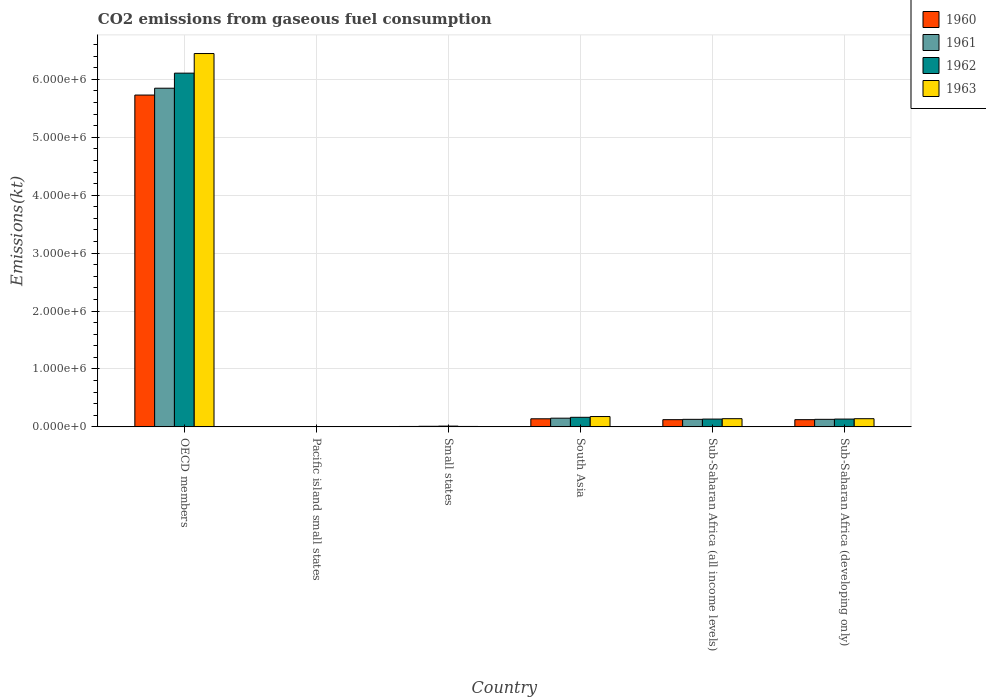How many different coloured bars are there?
Provide a short and direct response. 4. What is the label of the 1st group of bars from the left?
Make the answer very short. OECD members. What is the amount of CO2 emitted in 1962 in South Asia?
Give a very brief answer. 1.65e+05. Across all countries, what is the maximum amount of CO2 emitted in 1961?
Your answer should be compact. 5.85e+06. Across all countries, what is the minimum amount of CO2 emitted in 1961?
Provide a succinct answer. 332.61. In which country was the amount of CO2 emitted in 1960 minimum?
Ensure brevity in your answer.  Pacific island small states. What is the total amount of CO2 emitted in 1961 in the graph?
Keep it short and to the point. 6.27e+06. What is the difference between the amount of CO2 emitted in 1961 in Pacific island small states and that in Sub-Saharan Africa (all income levels)?
Offer a terse response. -1.30e+05. What is the difference between the amount of CO2 emitted in 1961 in OECD members and the amount of CO2 emitted in 1962 in Sub-Saharan Africa (developing only)?
Your response must be concise. 5.71e+06. What is the average amount of CO2 emitted in 1963 per country?
Offer a terse response. 1.15e+06. What is the difference between the amount of CO2 emitted of/in 1962 and amount of CO2 emitted of/in 1960 in OECD members?
Offer a very short reply. 3.78e+05. In how many countries, is the amount of CO2 emitted in 1962 greater than 6200000 kt?
Give a very brief answer. 0. What is the ratio of the amount of CO2 emitted in 1961 in Pacific island small states to that in Sub-Saharan Africa (developing only)?
Offer a terse response. 0. Is the difference between the amount of CO2 emitted in 1962 in Small states and Sub-Saharan Africa (developing only) greater than the difference between the amount of CO2 emitted in 1960 in Small states and Sub-Saharan Africa (developing only)?
Provide a succinct answer. No. What is the difference between the highest and the second highest amount of CO2 emitted in 1963?
Offer a very short reply. 6.30e+06. What is the difference between the highest and the lowest amount of CO2 emitted in 1963?
Your response must be concise. 6.45e+06. Is the sum of the amount of CO2 emitted in 1960 in Small states and South Asia greater than the maximum amount of CO2 emitted in 1962 across all countries?
Give a very brief answer. No. Is it the case that in every country, the sum of the amount of CO2 emitted in 1961 and amount of CO2 emitted in 1962 is greater than the sum of amount of CO2 emitted in 1963 and amount of CO2 emitted in 1960?
Give a very brief answer. No. What does the 2nd bar from the right in Pacific island small states represents?
Provide a short and direct response. 1962. Is it the case that in every country, the sum of the amount of CO2 emitted in 1963 and amount of CO2 emitted in 1962 is greater than the amount of CO2 emitted in 1960?
Provide a succinct answer. Yes. Are all the bars in the graph horizontal?
Give a very brief answer. No. How many countries are there in the graph?
Make the answer very short. 6. What is the difference between two consecutive major ticks on the Y-axis?
Your answer should be compact. 1.00e+06. How many legend labels are there?
Your answer should be compact. 4. How are the legend labels stacked?
Your answer should be very brief. Vertical. What is the title of the graph?
Provide a succinct answer. CO2 emissions from gaseous fuel consumption. What is the label or title of the Y-axis?
Give a very brief answer. Emissions(kt). What is the Emissions(kt) in 1960 in OECD members?
Your response must be concise. 5.73e+06. What is the Emissions(kt) of 1961 in OECD members?
Make the answer very short. 5.85e+06. What is the Emissions(kt) of 1962 in OECD members?
Offer a very short reply. 6.11e+06. What is the Emissions(kt) of 1963 in OECD members?
Keep it short and to the point. 6.45e+06. What is the Emissions(kt) of 1960 in Pacific island small states?
Keep it short and to the point. 309.51. What is the Emissions(kt) in 1961 in Pacific island small states?
Offer a very short reply. 332.61. What is the Emissions(kt) of 1962 in Pacific island small states?
Offer a terse response. 413.52. What is the Emissions(kt) in 1963 in Pacific island small states?
Your answer should be very brief. 433.59. What is the Emissions(kt) in 1960 in Small states?
Give a very brief answer. 7013.94. What is the Emissions(kt) of 1961 in Small states?
Make the answer very short. 1.02e+04. What is the Emissions(kt) in 1962 in Small states?
Give a very brief answer. 1.34e+04. What is the Emissions(kt) in 1963 in Small states?
Your answer should be compact. 7256.39. What is the Emissions(kt) in 1960 in South Asia?
Provide a short and direct response. 1.39e+05. What is the Emissions(kt) of 1961 in South Asia?
Your response must be concise. 1.50e+05. What is the Emissions(kt) of 1962 in South Asia?
Give a very brief answer. 1.65e+05. What is the Emissions(kt) of 1963 in South Asia?
Keep it short and to the point. 1.78e+05. What is the Emissions(kt) of 1960 in Sub-Saharan Africa (all income levels)?
Give a very brief answer. 1.25e+05. What is the Emissions(kt) in 1961 in Sub-Saharan Africa (all income levels)?
Provide a succinct answer. 1.30e+05. What is the Emissions(kt) in 1962 in Sub-Saharan Africa (all income levels)?
Make the answer very short. 1.35e+05. What is the Emissions(kt) of 1963 in Sub-Saharan Africa (all income levels)?
Your answer should be compact. 1.41e+05. What is the Emissions(kt) in 1960 in Sub-Saharan Africa (developing only)?
Make the answer very short. 1.24e+05. What is the Emissions(kt) of 1961 in Sub-Saharan Africa (developing only)?
Your answer should be very brief. 1.30e+05. What is the Emissions(kt) in 1962 in Sub-Saharan Africa (developing only)?
Offer a very short reply. 1.35e+05. What is the Emissions(kt) of 1963 in Sub-Saharan Africa (developing only)?
Ensure brevity in your answer.  1.41e+05. Across all countries, what is the maximum Emissions(kt) of 1960?
Provide a succinct answer. 5.73e+06. Across all countries, what is the maximum Emissions(kt) in 1961?
Your answer should be very brief. 5.85e+06. Across all countries, what is the maximum Emissions(kt) of 1962?
Your answer should be compact. 6.11e+06. Across all countries, what is the maximum Emissions(kt) in 1963?
Give a very brief answer. 6.45e+06. Across all countries, what is the minimum Emissions(kt) in 1960?
Your response must be concise. 309.51. Across all countries, what is the minimum Emissions(kt) of 1961?
Provide a succinct answer. 332.61. Across all countries, what is the minimum Emissions(kt) of 1962?
Provide a succinct answer. 413.52. Across all countries, what is the minimum Emissions(kt) of 1963?
Provide a short and direct response. 433.59. What is the total Emissions(kt) in 1960 in the graph?
Your answer should be compact. 6.13e+06. What is the total Emissions(kt) in 1961 in the graph?
Ensure brevity in your answer.  6.27e+06. What is the total Emissions(kt) of 1962 in the graph?
Keep it short and to the point. 6.56e+06. What is the total Emissions(kt) in 1963 in the graph?
Your answer should be very brief. 6.92e+06. What is the difference between the Emissions(kt) of 1960 in OECD members and that in Pacific island small states?
Your answer should be very brief. 5.73e+06. What is the difference between the Emissions(kt) in 1961 in OECD members and that in Pacific island small states?
Ensure brevity in your answer.  5.85e+06. What is the difference between the Emissions(kt) in 1962 in OECD members and that in Pacific island small states?
Provide a short and direct response. 6.11e+06. What is the difference between the Emissions(kt) in 1963 in OECD members and that in Pacific island small states?
Your answer should be compact. 6.45e+06. What is the difference between the Emissions(kt) of 1960 in OECD members and that in Small states?
Your response must be concise. 5.72e+06. What is the difference between the Emissions(kt) in 1961 in OECD members and that in Small states?
Offer a terse response. 5.84e+06. What is the difference between the Emissions(kt) in 1962 in OECD members and that in Small states?
Make the answer very short. 6.09e+06. What is the difference between the Emissions(kt) of 1963 in OECD members and that in Small states?
Your answer should be very brief. 6.44e+06. What is the difference between the Emissions(kt) of 1960 in OECD members and that in South Asia?
Ensure brevity in your answer.  5.59e+06. What is the difference between the Emissions(kt) of 1961 in OECD members and that in South Asia?
Offer a terse response. 5.70e+06. What is the difference between the Emissions(kt) in 1962 in OECD members and that in South Asia?
Your answer should be very brief. 5.94e+06. What is the difference between the Emissions(kt) in 1963 in OECD members and that in South Asia?
Make the answer very short. 6.27e+06. What is the difference between the Emissions(kt) of 1960 in OECD members and that in Sub-Saharan Africa (all income levels)?
Give a very brief answer. 5.60e+06. What is the difference between the Emissions(kt) of 1961 in OECD members and that in Sub-Saharan Africa (all income levels)?
Provide a short and direct response. 5.72e+06. What is the difference between the Emissions(kt) of 1962 in OECD members and that in Sub-Saharan Africa (all income levels)?
Your response must be concise. 5.97e+06. What is the difference between the Emissions(kt) in 1963 in OECD members and that in Sub-Saharan Africa (all income levels)?
Provide a short and direct response. 6.30e+06. What is the difference between the Emissions(kt) of 1960 in OECD members and that in Sub-Saharan Africa (developing only)?
Your answer should be compact. 5.61e+06. What is the difference between the Emissions(kt) in 1961 in OECD members and that in Sub-Saharan Africa (developing only)?
Keep it short and to the point. 5.72e+06. What is the difference between the Emissions(kt) of 1962 in OECD members and that in Sub-Saharan Africa (developing only)?
Your response must be concise. 5.97e+06. What is the difference between the Emissions(kt) of 1963 in OECD members and that in Sub-Saharan Africa (developing only)?
Your answer should be compact. 6.30e+06. What is the difference between the Emissions(kt) of 1960 in Pacific island small states and that in Small states?
Offer a terse response. -6704.42. What is the difference between the Emissions(kt) of 1961 in Pacific island small states and that in Small states?
Your answer should be very brief. -9836.23. What is the difference between the Emissions(kt) in 1962 in Pacific island small states and that in Small states?
Keep it short and to the point. -1.30e+04. What is the difference between the Emissions(kt) of 1963 in Pacific island small states and that in Small states?
Your response must be concise. -6822.8. What is the difference between the Emissions(kt) in 1960 in Pacific island small states and that in South Asia?
Your answer should be very brief. -1.39e+05. What is the difference between the Emissions(kt) of 1961 in Pacific island small states and that in South Asia?
Give a very brief answer. -1.50e+05. What is the difference between the Emissions(kt) in 1962 in Pacific island small states and that in South Asia?
Keep it short and to the point. -1.65e+05. What is the difference between the Emissions(kt) of 1963 in Pacific island small states and that in South Asia?
Your answer should be compact. -1.78e+05. What is the difference between the Emissions(kt) in 1960 in Pacific island small states and that in Sub-Saharan Africa (all income levels)?
Provide a short and direct response. -1.24e+05. What is the difference between the Emissions(kt) of 1961 in Pacific island small states and that in Sub-Saharan Africa (all income levels)?
Give a very brief answer. -1.30e+05. What is the difference between the Emissions(kt) of 1962 in Pacific island small states and that in Sub-Saharan Africa (all income levels)?
Offer a terse response. -1.34e+05. What is the difference between the Emissions(kt) of 1963 in Pacific island small states and that in Sub-Saharan Africa (all income levels)?
Keep it short and to the point. -1.41e+05. What is the difference between the Emissions(kt) of 1960 in Pacific island small states and that in Sub-Saharan Africa (developing only)?
Your answer should be very brief. -1.24e+05. What is the difference between the Emissions(kt) in 1961 in Pacific island small states and that in Sub-Saharan Africa (developing only)?
Keep it short and to the point. -1.30e+05. What is the difference between the Emissions(kt) in 1962 in Pacific island small states and that in Sub-Saharan Africa (developing only)?
Offer a very short reply. -1.34e+05. What is the difference between the Emissions(kt) in 1963 in Pacific island small states and that in Sub-Saharan Africa (developing only)?
Offer a terse response. -1.41e+05. What is the difference between the Emissions(kt) of 1960 in Small states and that in South Asia?
Provide a short and direct response. -1.32e+05. What is the difference between the Emissions(kt) in 1961 in Small states and that in South Asia?
Provide a succinct answer. -1.40e+05. What is the difference between the Emissions(kt) of 1962 in Small states and that in South Asia?
Offer a very short reply. -1.52e+05. What is the difference between the Emissions(kt) in 1963 in Small states and that in South Asia?
Ensure brevity in your answer.  -1.71e+05. What is the difference between the Emissions(kt) in 1960 in Small states and that in Sub-Saharan Africa (all income levels)?
Give a very brief answer. -1.17e+05. What is the difference between the Emissions(kt) in 1961 in Small states and that in Sub-Saharan Africa (all income levels)?
Ensure brevity in your answer.  -1.20e+05. What is the difference between the Emissions(kt) of 1962 in Small states and that in Sub-Saharan Africa (all income levels)?
Make the answer very short. -1.21e+05. What is the difference between the Emissions(kt) of 1963 in Small states and that in Sub-Saharan Africa (all income levels)?
Your answer should be very brief. -1.34e+05. What is the difference between the Emissions(kt) in 1960 in Small states and that in Sub-Saharan Africa (developing only)?
Offer a very short reply. -1.17e+05. What is the difference between the Emissions(kt) of 1961 in Small states and that in Sub-Saharan Africa (developing only)?
Provide a short and direct response. -1.20e+05. What is the difference between the Emissions(kt) of 1962 in Small states and that in Sub-Saharan Africa (developing only)?
Offer a terse response. -1.21e+05. What is the difference between the Emissions(kt) of 1963 in Small states and that in Sub-Saharan Africa (developing only)?
Your response must be concise. -1.34e+05. What is the difference between the Emissions(kt) of 1960 in South Asia and that in Sub-Saharan Africa (all income levels)?
Give a very brief answer. 1.50e+04. What is the difference between the Emissions(kt) of 1961 in South Asia and that in Sub-Saharan Africa (all income levels)?
Provide a succinct answer. 1.99e+04. What is the difference between the Emissions(kt) in 1962 in South Asia and that in Sub-Saharan Africa (all income levels)?
Provide a short and direct response. 3.05e+04. What is the difference between the Emissions(kt) in 1963 in South Asia and that in Sub-Saharan Africa (all income levels)?
Your answer should be compact. 3.72e+04. What is the difference between the Emissions(kt) of 1960 in South Asia and that in Sub-Saharan Africa (developing only)?
Offer a terse response. 1.50e+04. What is the difference between the Emissions(kt) in 1961 in South Asia and that in Sub-Saharan Africa (developing only)?
Provide a short and direct response. 1.99e+04. What is the difference between the Emissions(kt) of 1962 in South Asia and that in Sub-Saharan Africa (developing only)?
Offer a very short reply. 3.05e+04. What is the difference between the Emissions(kt) of 1963 in South Asia and that in Sub-Saharan Africa (developing only)?
Your answer should be very brief. 3.72e+04. What is the difference between the Emissions(kt) of 1960 in Sub-Saharan Africa (all income levels) and that in Sub-Saharan Africa (developing only)?
Provide a succinct answer. 25.95. What is the difference between the Emissions(kt) in 1961 in Sub-Saharan Africa (all income levels) and that in Sub-Saharan Africa (developing only)?
Your answer should be very brief. 26.08. What is the difference between the Emissions(kt) in 1962 in Sub-Saharan Africa (all income levels) and that in Sub-Saharan Africa (developing only)?
Make the answer very short. 26.17. What is the difference between the Emissions(kt) of 1963 in Sub-Saharan Africa (all income levels) and that in Sub-Saharan Africa (developing only)?
Make the answer very short. 30.19. What is the difference between the Emissions(kt) in 1960 in OECD members and the Emissions(kt) in 1961 in Pacific island small states?
Provide a succinct answer. 5.73e+06. What is the difference between the Emissions(kt) in 1960 in OECD members and the Emissions(kt) in 1962 in Pacific island small states?
Your response must be concise. 5.73e+06. What is the difference between the Emissions(kt) of 1960 in OECD members and the Emissions(kt) of 1963 in Pacific island small states?
Offer a very short reply. 5.73e+06. What is the difference between the Emissions(kt) of 1961 in OECD members and the Emissions(kt) of 1962 in Pacific island small states?
Your answer should be very brief. 5.85e+06. What is the difference between the Emissions(kt) in 1961 in OECD members and the Emissions(kt) in 1963 in Pacific island small states?
Your answer should be very brief. 5.85e+06. What is the difference between the Emissions(kt) of 1962 in OECD members and the Emissions(kt) of 1963 in Pacific island small states?
Offer a very short reply. 6.11e+06. What is the difference between the Emissions(kt) of 1960 in OECD members and the Emissions(kt) of 1961 in Small states?
Your answer should be very brief. 5.72e+06. What is the difference between the Emissions(kt) of 1960 in OECD members and the Emissions(kt) of 1962 in Small states?
Make the answer very short. 5.72e+06. What is the difference between the Emissions(kt) of 1960 in OECD members and the Emissions(kt) of 1963 in Small states?
Make the answer very short. 5.72e+06. What is the difference between the Emissions(kt) of 1961 in OECD members and the Emissions(kt) of 1962 in Small states?
Give a very brief answer. 5.83e+06. What is the difference between the Emissions(kt) of 1961 in OECD members and the Emissions(kt) of 1963 in Small states?
Make the answer very short. 5.84e+06. What is the difference between the Emissions(kt) in 1962 in OECD members and the Emissions(kt) in 1963 in Small states?
Ensure brevity in your answer.  6.10e+06. What is the difference between the Emissions(kt) of 1960 in OECD members and the Emissions(kt) of 1961 in South Asia?
Provide a short and direct response. 5.58e+06. What is the difference between the Emissions(kt) of 1960 in OECD members and the Emissions(kt) of 1962 in South Asia?
Your answer should be very brief. 5.56e+06. What is the difference between the Emissions(kt) in 1960 in OECD members and the Emissions(kt) in 1963 in South Asia?
Make the answer very short. 5.55e+06. What is the difference between the Emissions(kt) in 1961 in OECD members and the Emissions(kt) in 1962 in South Asia?
Your answer should be compact. 5.68e+06. What is the difference between the Emissions(kt) in 1961 in OECD members and the Emissions(kt) in 1963 in South Asia?
Ensure brevity in your answer.  5.67e+06. What is the difference between the Emissions(kt) of 1962 in OECD members and the Emissions(kt) of 1963 in South Asia?
Offer a terse response. 5.93e+06. What is the difference between the Emissions(kt) of 1960 in OECD members and the Emissions(kt) of 1961 in Sub-Saharan Africa (all income levels)?
Keep it short and to the point. 5.60e+06. What is the difference between the Emissions(kt) of 1960 in OECD members and the Emissions(kt) of 1962 in Sub-Saharan Africa (all income levels)?
Keep it short and to the point. 5.59e+06. What is the difference between the Emissions(kt) of 1960 in OECD members and the Emissions(kt) of 1963 in Sub-Saharan Africa (all income levels)?
Give a very brief answer. 5.59e+06. What is the difference between the Emissions(kt) of 1961 in OECD members and the Emissions(kt) of 1962 in Sub-Saharan Africa (all income levels)?
Your answer should be very brief. 5.71e+06. What is the difference between the Emissions(kt) of 1961 in OECD members and the Emissions(kt) of 1963 in Sub-Saharan Africa (all income levels)?
Offer a very short reply. 5.71e+06. What is the difference between the Emissions(kt) of 1962 in OECD members and the Emissions(kt) of 1963 in Sub-Saharan Africa (all income levels)?
Make the answer very short. 5.97e+06. What is the difference between the Emissions(kt) in 1960 in OECD members and the Emissions(kt) in 1961 in Sub-Saharan Africa (developing only)?
Your answer should be compact. 5.60e+06. What is the difference between the Emissions(kt) of 1960 in OECD members and the Emissions(kt) of 1962 in Sub-Saharan Africa (developing only)?
Your response must be concise. 5.59e+06. What is the difference between the Emissions(kt) of 1960 in OECD members and the Emissions(kt) of 1963 in Sub-Saharan Africa (developing only)?
Your answer should be very brief. 5.59e+06. What is the difference between the Emissions(kt) in 1961 in OECD members and the Emissions(kt) in 1962 in Sub-Saharan Africa (developing only)?
Provide a succinct answer. 5.71e+06. What is the difference between the Emissions(kt) of 1961 in OECD members and the Emissions(kt) of 1963 in Sub-Saharan Africa (developing only)?
Provide a succinct answer. 5.71e+06. What is the difference between the Emissions(kt) in 1962 in OECD members and the Emissions(kt) in 1963 in Sub-Saharan Africa (developing only)?
Make the answer very short. 5.97e+06. What is the difference between the Emissions(kt) in 1960 in Pacific island small states and the Emissions(kt) in 1961 in Small states?
Your answer should be very brief. -9859.33. What is the difference between the Emissions(kt) of 1960 in Pacific island small states and the Emissions(kt) of 1962 in Small states?
Keep it short and to the point. -1.31e+04. What is the difference between the Emissions(kt) in 1960 in Pacific island small states and the Emissions(kt) in 1963 in Small states?
Offer a terse response. -6946.87. What is the difference between the Emissions(kt) of 1961 in Pacific island small states and the Emissions(kt) of 1962 in Small states?
Provide a succinct answer. -1.31e+04. What is the difference between the Emissions(kt) of 1961 in Pacific island small states and the Emissions(kt) of 1963 in Small states?
Your answer should be compact. -6923.78. What is the difference between the Emissions(kt) in 1962 in Pacific island small states and the Emissions(kt) in 1963 in Small states?
Provide a succinct answer. -6842.87. What is the difference between the Emissions(kt) of 1960 in Pacific island small states and the Emissions(kt) of 1961 in South Asia?
Make the answer very short. -1.50e+05. What is the difference between the Emissions(kt) of 1960 in Pacific island small states and the Emissions(kt) of 1962 in South Asia?
Your response must be concise. -1.65e+05. What is the difference between the Emissions(kt) of 1960 in Pacific island small states and the Emissions(kt) of 1963 in South Asia?
Make the answer very short. -1.78e+05. What is the difference between the Emissions(kt) in 1961 in Pacific island small states and the Emissions(kt) in 1962 in South Asia?
Keep it short and to the point. -1.65e+05. What is the difference between the Emissions(kt) in 1961 in Pacific island small states and the Emissions(kt) in 1963 in South Asia?
Keep it short and to the point. -1.78e+05. What is the difference between the Emissions(kt) in 1962 in Pacific island small states and the Emissions(kt) in 1963 in South Asia?
Your response must be concise. -1.78e+05. What is the difference between the Emissions(kt) in 1960 in Pacific island small states and the Emissions(kt) in 1961 in Sub-Saharan Africa (all income levels)?
Your answer should be very brief. -1.30e+05. What is the difference between the Emissions(kt) of 1960 in Pacific island small states and the Emissions(kt) of 1962 in Sub-Saharan Africa (all income levels)?
Your answer should be very brief. -1.34e+05. What is the difference between the Emissions(kt) of 1960 in Pacific island small states and the Emissions(kt) of 1963 in Sub-Saharan Africa (all income levels)?
Your answer should be very brief. -1.41e+05. What is the difference between the Emissions(kt) of 1961 in Pacific island small states and the Emissions(kt) of 1962 in Sub-Saharan Africa (all income levels)?
Keep it short and to the point. -1.34e+05. What is the difference between the Emissions(kt) in 1961 in Pacific island small states and the Emissions(kt) in 1963 in Sub-Saharan Africa (all income levels)?
Offer a very short reply. -1.41e+05. What is the difference between the Emissions(kt) of 1962 in Pacific island small states and the Emissions(kt) of 1963 in Sub-Saharan Africa (all income levels)?
Provide a succinct answer. -1.41e+05. What is the difference between the Emissions(kt) of 1960 in Pacific island small states and the Emissions(kt) of 1961 in Sub-Saharan Africa (developing only)?
Offer a terse response. -1.30e+05. What is the difference between the Emissions(kt) in 1960 in Pacific island small states and the Emissions(kt) in 1962 in Sub-Saharan Africa (developing only)?
Make the answer very short. -1.34e+05. What is the difference between the Emissions(kt) in 1960 in Pacific island small states and the Emissions(kt) in 1963 in Sub-Saharan Africa (developing only)?
Provide a short and direct response. -1.41e+05. What is the difference between the Emissions(kt) of 1961 in Pacific island small states and the Emissions(kt) of 1962 in Sub-Saharan Africa (developing only)?
Give a very brief answer. -1.34e+05. What is the difference between the Emissions(kt) of 1961 in Pacific island small states and the Emissions(kt) of 1963 in Sub-Saharan Africa (developing only)?
Your answer should be compact. -1.41e+05. What is the difference between the Emissions(kt) of 1962 in Pacific island small states and the Emissions(kt) of 1963 in Sub-Saharan Africa (developing only)?
Your answer should be compact. -1.41e+05. What is the difference between the Emissions(kt) in 1960 in Small states and the Emissions(kt) in 1961 in South Asia?
Keep it short and to the point. -1.43e+05. What is the difference between the Emissions(kt) in 1960 in Small states and the Emissions(kt) in 1962 in South Asia?
Offer a terse response. -1.58e+05. What is the difference between the Emissions(kt) in 1960 in Small states and the Emissions(kt) in 1963 in South Asia?
Give a very brief answer. -1.71e+05. What is the difference between the Emissions(kt) of 1961 in Small states and the Emissions(kt) of 1962 in South Asia?
Give a very brief answer. -1.55e+05. What is the difference between the Emissions(kt) in 1961 in Small states and the Emissions(kt) in 1963 in South Asia?
Provide a short and direct response. -1.68e+05. What is the difference between the Emissions(kt) of 1962 in Small states and the Emissions(kt) of 1963 in South Asia?
Your response must be concise. -1.65e+05. What is the difference between the Emissions(kt) in 1960 in Small states and the Emissions(kt) in 1961 in Sub-Saharan Africa (all income levels)?
Keep it short and to the point. -1.23e+05. What is the difference between the Emissions(kt) of 1960 in Small states and the Emissions(kt) of 1962 in Sub-Saharan Africa (all income levels)?
Give a very brief answer. -1.28e+05. What is the difference between the Emissions(kt) of 1960 in Small states and the Emissions(kt) of 1963 in Sub-Saharan Africa (all income levels)?
Ensure brevity in your answer.  -1.34e+05. What is the difference between the Emissions(kt) in 1961 in Small states and the Emissions(kt) in 1962 in Sub-Saharan Africa (all income levels)?
Your response must be concise. -1.25e+05. What is the difference between the Emissions(kt) of 1961 in Small states and the Emissions(kt) of 1963 in Sub-Saharan Africa (all income levels)?
Your answer should be compact. -1.31e+05. What is the difference between the Emissions(kt) of 1962 in Small states and the Emissions(kt) of 1963 in Sub-Saharan Africa (all income levels)?
Ensure brevity in your answer.  -1.28e+05. What is the difference between the Emissions(kt) of 1960 in Small states and the Emissions(kt) of 1961 in Sub-Saharan Africa (developing only)?
Provide a succinct answer. -1.23e+05. What is the difference between the Emissions(kt) in 1960 in Small states and the Emissions(kt) in 1962 in Sub-Saharan Africa (developing only)?
Provide a short and direct response. -1.28e+05. What is the difference between the Emissions(kt) in 1960 in Small states and the Emissions(kt) in 1963 in Sub-Saharan Africa (developing only)?
Ensure brevity in your answer.  -1.34e+05. What is the difference between the Emissions(kt) in 1961 in Small states and the Emissions(kt) in 1962 in Sub-Saharan Africa (developing only)?
Keep it short and to the point. -1.25e+05. What is the difference between the Emissions(kt) in 1961 in Small states and the Emissions(kt) in 1963 in Sub-Saharan Africa (developing only)?
Your answer should be very brief. -1.31e+05. What is the difference between the Emissions(kt) of 1962 in Small states and the Emissions(kt) of 1963 in Sub-Saharan Africa (developing only)?
Ensure brevity in your answer.  -1.28e+05. What is the difference between the Emissions(kt) in 1960 in South Asia and the Emissions(kt) in 1961 in Sub-Saharan Africa (all income levels)?
Your answer should be very brief. 9266.84. What is the difference between the Emissions(kt) of 1960 in South Asia and the Emissions(kt) of 1962 in Sub-Saharan Africa (all income levels)?
Give a very brief answer. 4699.93. What is the difference between the Emissions(kt) of 1960 in South Asia and the Emissions(kt) of 1963 in Sub-Saharan Africa (all income levels)?
Offer a terse response. -1820.31. What is the difference between the Emissions(kt) of 1961 in South Asia and the Emissions(kt) of 1962 in Sub-Saharan Africa (all income levels)?
Give a very brief answer. 1.53e+04. What is the difference between the Emissions(kt) in 1961 in South Asia and the Emissions(kt) in 1963 in Sub-Saharan Africa (all income levels)?
Your response must be concise. 8808.5. What is the difference between the Emissions(kt) in 1962 in South Asia and the Emissions(kt) in 1963 in Sub-Saharan Africa (all income levels)?
Your response must be concise. 2.40e+04. What is the difference between the Emissions(kt) of 1960 in South Asia and the Emissions(kt) of 1961 in Sub-Saharan Africa (developing only)?
Ensure brevity in your answer.  9292.91. What is the difference between the Emissions(kt) of 1960 in South Asia and the Emissions(kt) of 1962 in Sub-Saharan Africa (developing only)?
Give a very brief answer. 4726.11. What is the difference between the Emissions(kt) of 1960 in South Asia and the Emissions(kt) of 1963 in Sub-Saharan Africa (developing only)?
Offer a very short reply. -1790.11. What is the difference between the Emissions(kt) of 1961 in South Asia and the Emissions(kt) of 1962 in Sub-Saharan Africa (developing only)?
Ensure brevity in your answer.  1.54e+04. What is the difference between the Emissions(kt) in 1961 in South Asia and the Emissions(kt) in 1963 in Sub-Saharan Africa (developing only)?
Your response must be concise. 8838.69. What is the difference between the Emissions(kt) in 1962 in South Asia and the Emissions(kt) in 1963 in Sub-Saharan Africa (developing only)?
Give a very brief answer. 2.40e+04. What is the difference between the Emissions(kt) of 1960 in Sub-Saharan Africa (all income levels) and the Emissions(kt) of 1961 in Sub-Saharan Africa (developing only)?
Provide a succinct answer. -5693.06. What is the difference between the Emissions(kt) in 1960 in Sub-Saharan Africa (all income levels) and the Emissions(kt) in 1962 in Sub-Saharan Africa (developing only)?
Ensure brevity in your answer.  -1.03e+04. What is the difference between the Emissions(kt) of 1960 in Sub-Saharan Africa (all income levels) and the Emissions(kt) of 1963 in Sub-Saharan Africa (developing only)?
Make the answer very short. -1.68e+04. What is the difference between the Emissions(kt) in 1961 in Sub-Saharan Africa (all income levels) and the Emissions(kt) in 1962 in Sub-Saharan Africa (developing only)?
Your answer should be compact. -4540.73. What is the difference between the Emissions(kt) of 1961 in Sub-Saharan Africa (all income levels) and the Emissions(kt) of 1963 in Sub-Saharan Africa (developing only)?
Offer a very short reply. -1.11e+04. What is the difference between the Emissions(kt) of 1962 in Sub-Saharan Africa (all income levels) and the Emissions(kt) of 1963 in Sub-Saharan Africa (developing only)?
Make the answer very short. -6490.04. What is the average Emissions(kt) in 1960 per country?
Offer a very short reply. 1.02e+06. What is the average Emissions(kt) in 1961 per country?
Provide a succinct answer. 1.04e+06. What is the average Emissions(kt) in 1962 per country?
Ensure brevity in your answer.  1.09e+06. What is the average Emissions(kt) of 1963 per country?
Your response must be concise. 1.15e+06. What is the difference between the Emissions(kt) in 1960 and Emissions(kt) in 1961 in OECD members?
Your answer should be compact. -1.18e+05. What is the difference between the Emissions(kt) in 1960 and Emissions(kt) in 1962 in OECD members?
Your answer should be very brief. -3.78e+05. What is the difference between the Emissions(kt) of 1960 and Emissions(kt) of 1963 in OECD members?
Make the answer very short. -7.17e+05. What is the difference between the Emissions(kt) of 1961 and Emissions(kt) of 1962 in OECD members?
Make the answer very short. -2.60e+05. What is the difference between the Emissions(kt) of 1961 and Emissions(kt) of 1963 in OECD members?
Provide a succinct answer. -5.99e+05. What is the difference between the Emissions(kt) in 1962 and Emissions(kt) in 1963 in OECD members?
Give a very brief answer. -3.39e+05. What is the difference between the Emissions(kt) of 1960 and Emissions(kt) of 1961 in Pacific island small states?
Make the answer very short. -23.1. What is the difference between the Emissions(kt) in 1960 and Emissions(kt) in 1962 in Pacific island small states?
Your answer should be very brief. -104. What is the difference between the Emissions(kt) in 1960 and Emissions(kt) in 1963 in Pacific island small states?
Offer a very short reply. -124.08. What is the difference between the Emissions(kt) in 1961 and Emissions(kt) in 1962 in Pacific island small states?
Offer a terse response. -80.91. What is the difference between the Emissions(kt) of 1961 and Emissions(kt) of 1963 in Pacific island small states?
Your answer should be very brief. -100.98. What is the difference between the Emissions(kt) of 1962 and Emissions(kt) of 1963 in Pacific island small states?
Provide a succinct answer. -20.07. What is the difference between the Emissions(kt) of 1960 and Emissions(kt) of 1961 in Small states?
Keep it short and to the point. -3154.91. What is the difference between the Emissions(kt) in 1960 and Emissions(kt) in 1962 in Small states?
Your answer should be compact. -6374.72. What is the difference between the Emissions(kt) in 1960 and Emissions(kt) in 1963 in Small states?
Provide a succinct answer. -242.45. What is the difference between the Emissions(kt) of 1961 and Emissions(kt) of 1962 in Small states?
Provide a short and direct response. -3219.81. What is the difference between the Emissions(kt) of 1961 and Emissions(kt) of 1963 in Small states?
Your answer should be very brief. 2912.46. What is the difference between the Emissions(kt) of 1962 and Emissions(kt) of 1963 in Small states?
Give a very brief answer. 6132.27. What is the difference between the Emissions(kt) in 1960 and Emissions(kt) in 1961 in South Asia?
Keep it short and to the point. -1.06e+04. What is the difference between the Emissions(kt) of 1960 and Emissions(kt) of 1962 in South Asia?
Your answer should be very brief. -2.58e+04. What is the difference between the Emissions(kt) in 1960 and Emissions(kt) in 1963 in South Asia?
Offer a very short reply. -3.90e+04. What is the difference between the Emissions(kt) in 1961 and Emissions(kt) in 1962 in South Asia?
Ensure brevity in your answer.  -1.52e+04. What is the difference between the Emissions(kt) in 1961 and Emissions(kt) in 1963 in South Asia?
Make the answer very short. -2.84e+04. What is the difference between the Emissions(kt) in 1962 and Emissions(kt) in 1963 in South Asia?
Provide a succinct answer. -1.32e+04. What is the difference between the Emissions(kt) in 1960 and Emissions(kt) in 1961 in Sub-Saharan Africa (all income levels)?
Your response must be concise. -5719.13. What is the difference between the Emissions(kt) in 1960 and Emissions(kt) in 1962 in Sub-Saharan Africa (all income levels)?
Your response must be concise. -1.03e+04. What is the difference between the Emissions(kt) of 1960 and Emissions(kt) of 1963 in Sub-Saharan Africa (all income levels)?
Keep it short and to the point. -1.68e+04. What is the difference between the Emissions(kt) in 1961 and Emissions(kt) in 1962 in Sub-Saharan Africa (all income levels)?
Ensure brevity in your answer.  -4566.91. What is the difference between the Emissions(kt) in 1961 and Emissions(kt) in 1963 in Sub-Saharan Africa (all income levels)?
Your response must be concise. -1.11e+04. What is the difference between the Emissions(kt) of 1962 and Emissions(kt) of 1963 in Sub-Saharan Africa (all income levels)?
Your response must be concise. -6520.24. What is the difference between the Emissions(kt) of 1960 and Emissions(kt) of 1961 in Sub-Saharan Africa (developing only)?
Keep it short and to the point. -5719.01. What is the difference between the Emissions(kt) in 1960 and Emissions(kt) in 1962 in Sub-Saharan Africa (developing only)?
Offer a very short reply. -1.03e+04. What is the difference between the Emissions(kt) of 1960 and Emissions(kt) of 1963 in Sub-Saharan Africa (developing only)?
Give a very brief answer. -1.68e+04. What is the difference between the Emissions(kt) of 1961 and Emissions(kt) of 1962 in Sub-Saharan Africa (developing only)?
Your answer should be very brief. -4566.81. What is the difference between the Emissions(kt) in 1961 and Emissions(kt) in 1963 in Sub-Saharan Africa (developing only)?
Provide a short and direct response. -1.11e+04. What is the difference between the Emissions(kt) in 1962 and Emissions(kt) in 1963 in Sub-Saharan Africa (developing only)?
Provide a short and direct response. -6516.22. What is the ratio of the Emissions(kt) of 1960 in OECD members to that in Pacific island small states?
Offer a very short reply. 1.85e+04. What is the ratio of the Emissions(kt) in 1961 in OECD members to that in Pacific island small states?
Your answer should be very brief. 1.76e+04. What is the ratio of the Emissions(kt) of 1962 in OECD members to that in Pacific island small states?
Your response must be concise. 1.48e+04. What is the ratio of the Emissions(kt) of 1963 in OECD members to that in Pacific island small states?
Offer a terse response. 1.49e+04. What is the ratio of the Emissions(kt) of 1960 in OECD members to that in Small states?
Provide a short and direct response. 816.87. What is the ratio of the Emissions(kt) in 1961 in OECD members to that in Small states?
Offer a very short reply. 575.06. What is the ratio of the Emissions(kt) of 1962 in OECD members to that in Small states?
Your answer should be compact. 456.18. What is the ratio of the Emissions(kt) in 1963 in OECD members to that in Small states?
Your response must be concise. 888.35. What is the ratio of the Emissions(kt) in 1960 in OECD members to that in South Asia?
Your answer should be very brief. 41.08. What is the ratio of the Emissions(kt) of 1961 in OECD members to that in South Asia?
Ensure brevity in your answer.  38.95. What is the ratio of the Emissions(kt) of 1962 in OECD members to that in South Asia?
Your response must be concise. 36.95. What is the ratio of the Emissions(kt) of 1963 in OECD members to that in South Asia?
Provide a short and direct response. 36.11. What is the ratio of the Emissions(kt) in 1960 in OECD members to that in Sub-Saharan Africa (all income levels)?
Offer a terse response. 46.02. What is the ratio of the Emissions(kt) of 1961 in OECD members to that in Sub-Saharan Africa (all income levels)?
Offer a very short reply. 44.91. What is the ratio of the Emissions(kt) of 1962 in OECD members to that in Sub-Saharan Africa (all income levels)?
Your answer should be very brief. 45.31. What is the ratio of the Emissions(kt) in 1963 in OECD members to that in Sub-Saharan Africa (all income levels)?
Give a very brief answer. 45.62. What is the ratio of the Emissions(kt) of 1960 in OECD members to that in Sub-Saharan Africa (developing only)?
Provide a short and direct response. 46.03. What is the ratio of the Emissions(kt) in 1961 in OECD members to that in Sub-Saharan Africa (developing only)?
Make the answer very short. 44.92. What is the ratio of the Emissions(kt) of 1962 in OECD members to that in Sub-Saharan Africa (developing only)?
Make the answer very short. 45.32. What is the ratio of the Emissions(kt) of 1963 in OECD members to that in Sub-Saharan Africa (developing only)?
Offer a very short reply. 45.63. What is the ratio of the Emissions(kt) of 1960 in Pacific island small states to that in Small states?
Ensure brevity in your answer.  0.04. What is the ratio of the Emissions(kt) in 1961 in Pacific island small states to that in Small states?
Keep it short and to the point. 0.03. What is the ratio of the Emissions(kt) in 1962 in Pacific island small states to that in Small states?
Provide a short and direct response. 0.03. What is the ratio of the Emissions(kt) in 1963 in Pacific island small states to that in Small states?
Your answer should be compact. 0.06. What is the ratio of the Emissions(kt) of 1960 in Pacific island small states to that in South Asia?
Keep it short and to the point. 0. What is the ratio of the Emissions(kt) in 1961 in Pacific island small states to that in South Asia?
Provide a short and direct response. 0. What is the ratio of the Emissions(kt) in 1962 in Pacific island small states to that in South Asia?
Keep it short and to the point. 0. What is the ratio of the Emissions(kt) in 1963 in Pacific island small states to that in South Asia?
Your answer should be compact. 0. What is the ratio of the Emissions(kt) in 1960 in Pacific island small states to that in Sub-Saharan Africa (all income levels)?
Keep it short and to the point. 0. What is the ratio of the Emissions(kt) in 1961 in Pacific island small states to that in Sub-Saharan Africa (all income levels)?
Make the answer very short. 0. What is the ratio of the Emissions(kt) of 1962 in Pacific island small states to that in Sub-Saharan Africa (all income levels)?
Your response must be concise. 0. What is the ratio of the Emissions(kt) of 1963 in Pacific island small states to that in Sub-Saharan Africa (all income levels)?
Keep it short and to the point. 0. What is the ratio of the Emissions(kt) of 1960 in Pacific island small states to that in Sub-Saharan Africa (developing only)?
Give a very brief answer. 0. What is the ratio of the Emissions(kt) in 1961 in Pacific island small states to that in Sub-Saharan Africa (developing only)?
Provide a short and direct response. 0. What is the ratio of the Emissions(kt) of 1962 in Pacific island small states to that in Sub-Saharan Africa (developing only)?
Ensure brevity in your answer.  0. What is the ratio of the Emissions(kt) of 1963 in Pacific island small states to that in Sub-Saharan Africa (developing only)?
Make the answer very short. 0. What is the ratio of the Emissions(kt) of 1960 in Small states to that in South Asia?
Offer a very short reply. 0.05. What is the ratio of the Emissions(kt) in 1961 in Small states to that in South Asia?
Your answer should be compact. 0.07. What is the ratio of the Emissions(kt) of 1962 in Small states to that in South Asia?
Provide a short and direct response. 0.08. What is the ratio of the Emissions(kt) in 1963 in Small states to that in South Asia?
Your answer should be compact. 0.04. What is the ratio of the Emissions(kt) of 1960 in Small states to that in Sub-Saharan Africa (all income levels)?
Ensure brevity in your answer.  0.06. What is the ratio of the Emissions(kt) in 1961 in Small states to that in Sub-Saharan Africa (all income levels)?
Your answer should be very brief. 0.08. What is the ratio of the Emissions(kt) in 1962 in Small states to that in Sub-Saharan Africa (all income levels)?
Ensure brevity in your answer.  0.1. What is the ratio of the Emissions(kt) in 1963 in Small states to that in Sub-Saharan Africa (all income levels)?
Your answer should be very brief. 0.05. What is the ratio of the Emissions(kt) of 1960 in Small states to that in Sub-Saharan Africa (developing only)?
Make the answer very short. 0.06. What is the ratio of the Emissions(kt) of 1961 in Small states to that in Sub-Saharan Africa (developing only)?
Provide a succinct answer. 0.08. What is the ratio of the Emissions(kt) of 1962 in Small states to that in Sub-Saharan Africa (developing only)?
Provide a short and direct response. 0.1. What is the ratio of the Emissions(kt) in 1963 in Small states to that in Sub-Saharan Africa (developing only)?
Make the answer very short. 0.05. What is the ratio of the Emissions(kt) of 1960 in South Asia to that in Sub-Saharan Africa (all income levels)?
Offer a very short reply. 1.12. What is the ratio of the Emissions(kt) in 1961 in South Asia to that in Sub-Saharan Africa (all income levels)?
Your answer should be very brief. 1.15. What is the ratio of the Emissions(kt) of 1962 in South Asia to that in Sub-Saharan Africa (all income levels)?
Your answer should be compact. 1.23. What is the ratio of the Emissions(kt) of 1963 in South Asia to that in Sub-Saharan Africa (all income levels)?
Offer a terse response. 1.26. What is the ratio of the Emissions(kt) in 1960 in South Asia to that in Sub-Saharan Africa (developing only)?
Offer a terse response. 1.12. What is the ratio of the Emissions(kt) in 1961 in South Asia to that in Sub-Saharan Africa (developing only)?
Keep it short and to the point. 1.15. What is the ratio of the Emissions(kt) of 1962 in South Asia to that in Sub-Saharan Africa (developing only)?
Give a very brief answer. 1.23. What is the ratio of the Emissions(kt) in 1963 in South Asia to that in Sub-Saharan Africa (developing only)?
Offer a terse response. 1.26. What is the difference between the highest and the second highest Emissions(kt) of 1960?
Make the answer very short. 5.59e+06. What is the difference between the highest and the second highest Emissions(kt) in 1961?
Make the answer very short. 5.70e+06. What is the difference between the highest and the second highest Emissions(kt) in 1962?
Provide a succinct answer. 5.94e+06. What is the difference between the highest and the second highest Emissions(kt) of 1963?
Your answer should be very brief. 6.27e+06. What is the difference between the highest and the lowest Emissions(kt) in 1960?
Offer a very short reply. 5.73e+06. What is the difference between the highest and the lowest Emissions(kt) in 1961?
Your answer should be compact. 5.85e+06. What is the difference between the highest and the lowest Emissions(kt) in 1962?
Offer a very short reply. 6.11e+06. What is the difference between the highest and the lowest Emissions(kt) of 1963?
Offer a terse response. 6.45e+06. 